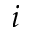Convert formula to latex. <formula><loc_0><loc_0><loc_500><loc_500>i</formula> 